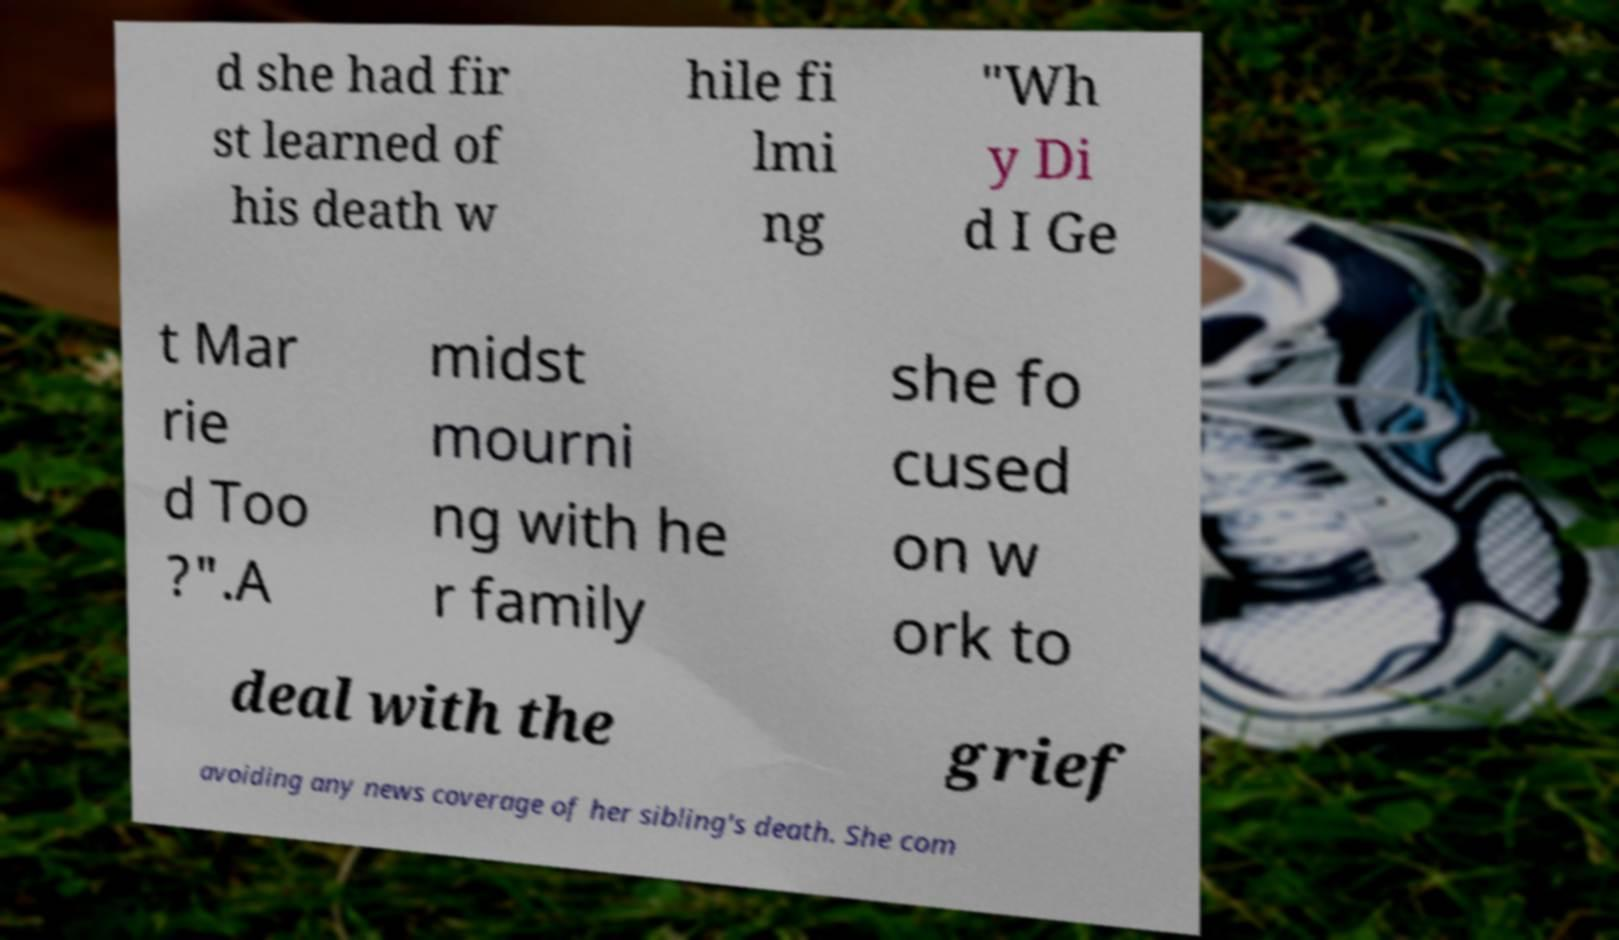I need the written content from this picture converted into text. Can you do that? d she had fir st learned of his death w hile fi lmi ng "Wh y Di d I Ge t Mar rie d Too ?".A midst mourni ng with he r family she fo cused on w ork to deal with the grief avoiding any news coverage of her sibling's death. She com 